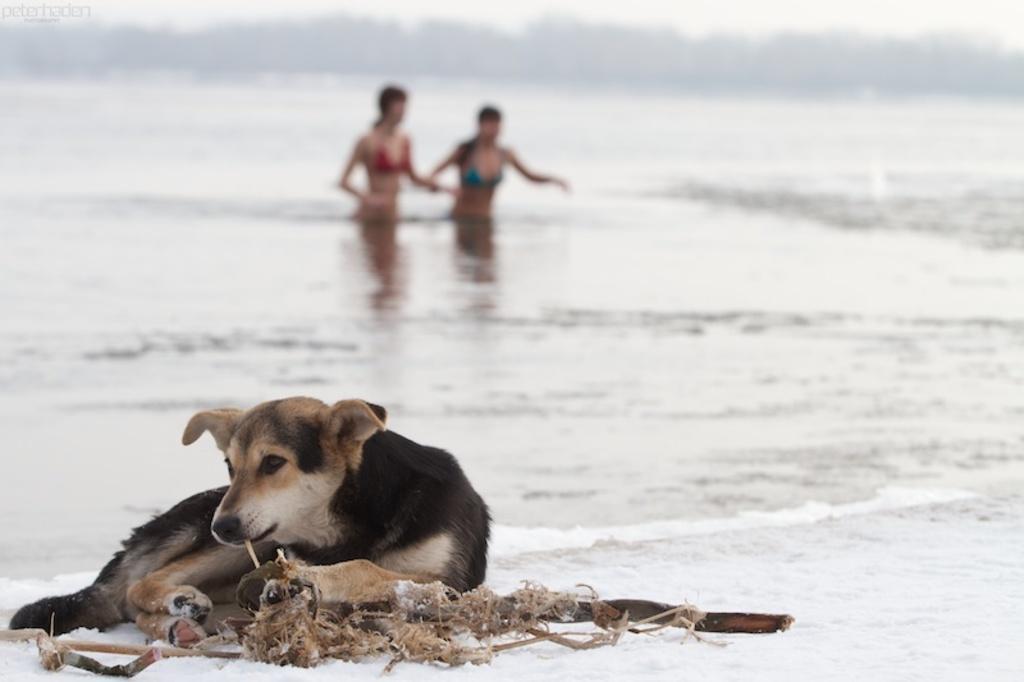Could you give a brief overview of what you see in this image? In this image there is a dog sat on the beach side, in the background of the image there are two women coming out of the water. 